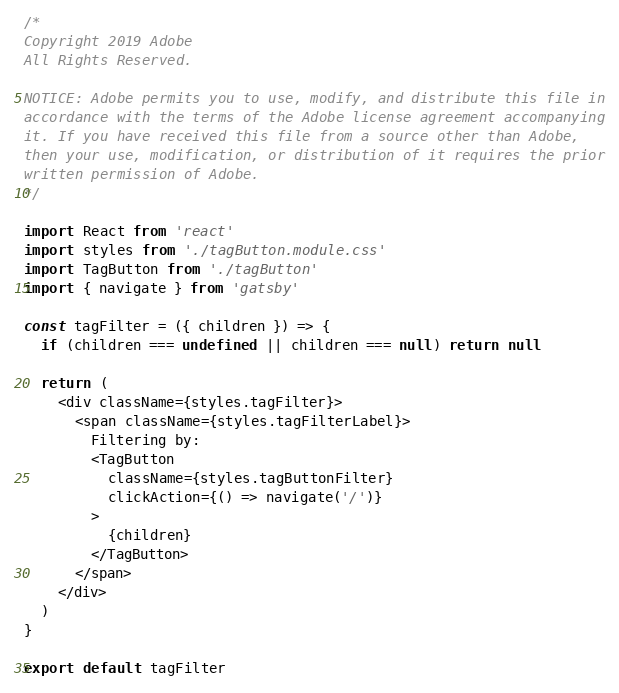<code> <loc_0><loc_0><loc_500><loc_500><_JavaScript_>/*
Copyright 2019 Adobe
All Rights Reserved.

NOTICE: Adobe permits you to use, modify, and distribute this file in
accordance with the terms of the Adobe license agreement accompanying
it. If you have received this file from a source other than Adobe,
then your use, modification, or distribution of it requires the prior
written permission of Adobe. 
*/

import React from 'react'
import styles from './tagButton.module.css'
import TagButton from './tagButton'
import { navigate } from 'gatsby'

const tagFilter = ({ children }) => {
  if (children === undefined || children === null) return null

  return (
    <div className={styles.tagFilter}>
      <span className={styles.tagFilterLabel}>
        Filtering by:
        <TagButton
          className={styles.tagButtonFilter}
          clickAction={() => navigate('/')}
        >
          {children}
        </TagButton>
      </span>
    </div>
  )
}

export default tagFilter
</code> 